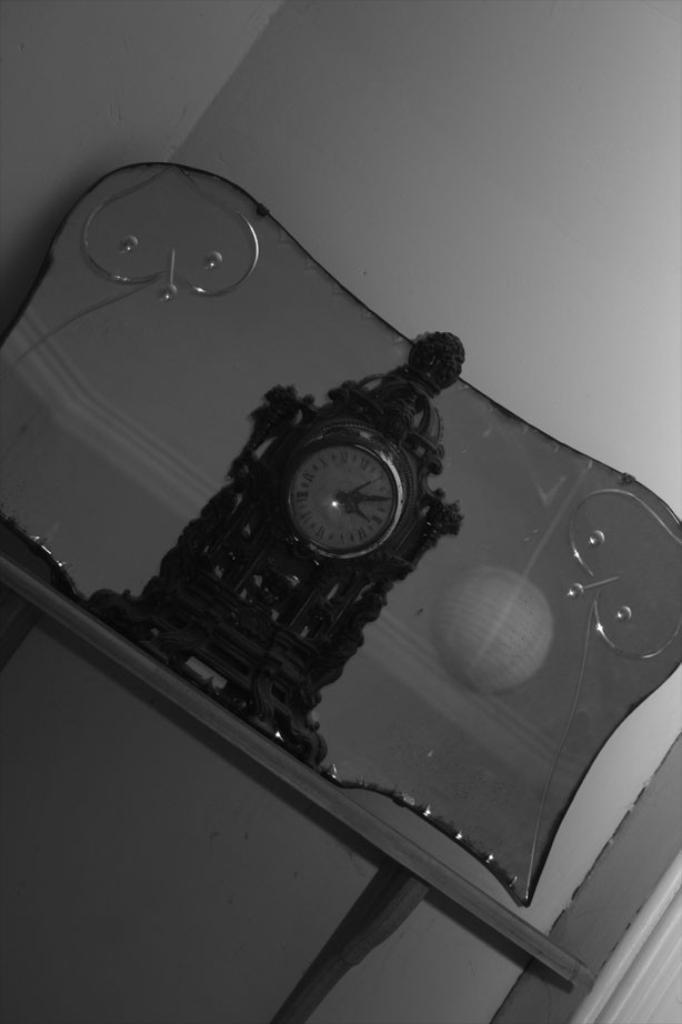Could you give a brief overview of what you see in this image? This is a black and white pic. In this image we can see a clock and a mirror on a table at the wall and on the right side at the bottom corner we can see an objects and on the glass we can see the reflection of a spherical object and ceiling. 